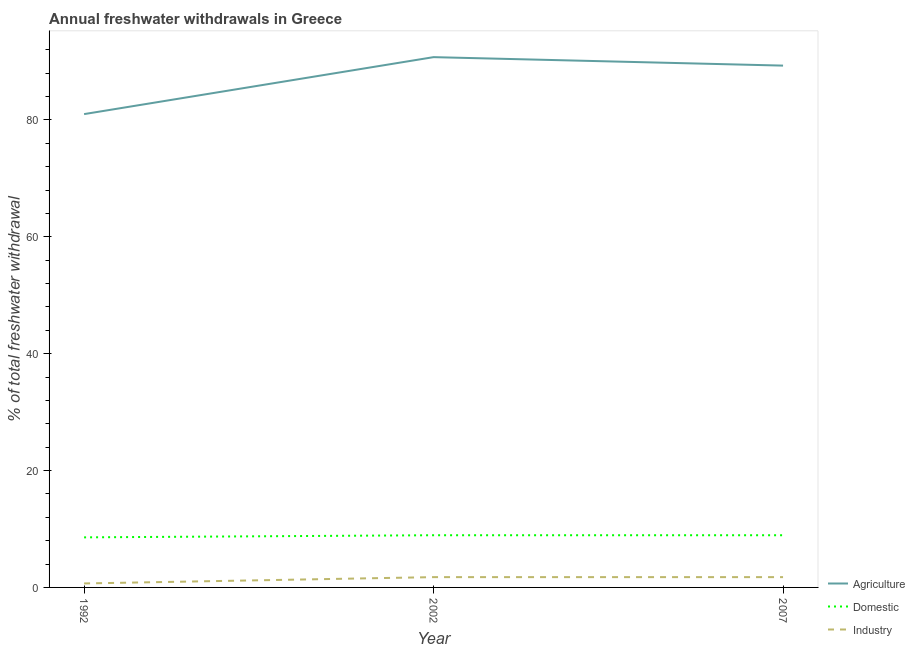What is the percentage of freshwater withdrawal for industry in 2007?
Provide a short and direct response. 1.76. Across all years, what is the maximum percentage of freshwater withdrawal for domestic purposes?
Offer a terse response. 8.93. Across all years, what is the minimum percentage of freshwater withdrawal for agriculture?
Your answer should be very brief. 81. In which year was the percentage of freshwater withdrawal for agriculture minimum?
Offer a terse response. 1992. What is the total percentage of freshwater withdrawal for agriculture in the graph?
Your answer should be compact. 261.05. What is the difference between the percentage of freshwater withdrawal for agriculture in 1992 and that in 2002?
Your answer should be very brief. -9.75. What is the difference between the percentage of freshwater withdrawal for agriculture in 1992 and the percentage of freshwater withdrawal for domestic purposes in 2002?
Make the answer very short. 72.07. What is the average percentage of freshwater withdrawal for domestic purposes per year?
Make the answer very short. 8.81. In the year 2002, what is the difference between the percentage of freshwater withdrawal for domestic purposes and percentage of freshwater withdrawal for industry?
Your answer should be very brief. 7.17. In how many years, is the percentage of freshwater withdrawal for agriculture greater than 48 %?
Make the answer very short. 3. What is the ratio of the percentage of freshwater withdrawal for industry in 2002 to that in 2007?
Give a very brief answer. 1. Is the percentage of freshwater withdrawal for industry in 2002 less than that in 2007?
Provide a succinct answer. No. What is the difference between the highest and the second highest percentage of freshwater withdrawal for agriculture?
Provide a succinct answer. 1.45. What is the difference between the highest and the lowest percentage of freshwater withdrawal for agriculture?
Give a very brief answer. 9.75. Is the percentage of freshwater withdrawal for domestic purposes strictly less than the percentage of freshwater withdrawal for industry over the years?
Your answer should be very brief. No. How many lines are there?
Your answer should be compact. 3. How many years are there in the graph?
Ensure brevity in your answer.  3. What is the difference between two consecutive major ticks on the Y-axis?
Give a very brief answer. 20. How many legend labels are there?
Provide a succinct answer. 3. How are the legend labels stacked?
Make the answer very short. Vertical. What is the title of the graph?
Offer a very short reply. Annual freshwater withdrawals in Greece. What is the label or title of the Y-axis?
Offer a terse response. % of total freshwater withdrawal. What is the % of total freshwater withdrawal of Domestic in 1992?
Provide a succinct answer. 8.57. What is the % of total freshwater withdrawal in Industry in 1992?
Provide a short and direct response. 0.68. What is the % of total freshwater withdrawal of Agriculture in 2002?
Offer a terse response. 90.75. What is the % of total freshwater withdrawal in Domestic in 2002?
Offer a very short reply. 8.93. What is the % of total freshwater withdrawal in Industry in 2002?
Offer a very short reply. 1.76. What is the % of total freshwater withdrawal in Agriculture in 2007?
Your answer should be very brief. 89.3. What is the % of total freshwater withdrawal of Domestic in 2007?
Ensure brevity in your answer.  8.93. What is the % of total freshwater withdrawal of Industry in 2007?
Keep it short and to the point. 1.76. Across all years, what is the maximum % of total freshwater withdrawal in Agriculture?
Your answer should be compact. 90.75. Across all years, what is the maximum % of total freshwater withdrawal in Domestic?
Your response must be concise. 8.93. Across all years, what is the maximum % of total freshwater withdrawal in Industry?
Offer a terse response. 1.76. Across all years, what is the minimum % of total freshwater withdrawal of Domestic?
Your answer should be very brief. 8.57. Across all years, what is the minimum % of total freshwater withdrawal of Industry?
Provide a short and direct response. 0.68. What is the total % of total freshwater withdrawal in Agriculture in the graph?
Provide a succinct answer. 261.05. What is the total % of total freshwater withdrawal of Domestic in the graph?
Your answer should be compact. 26.43. What is the total % of total freshwater withdrawal in Industry in the graph?
Provide a short and direct response. 4.21. What is the difference between the % of total freshwater withdrawal in Agriculture in 1992 and that in 2002?
Provide a short and direct response. -9.75. What is the difference between the % of total freshwater withdrawal in Domestic in 1992 and that in 2002?
Your answer should be compact. -0.36. What is the difference between the % of total freshwater withdrawal of Industry in 1992 and that in 2002?
Your answer should be compact. -1.08. What is the difference between the % of total freshwater withdrawal of Agriculture in 1992 and that in 2007?
Give a very brief answer. -8.3. What is the difference between the % of total freshwater withdrawal of Domestic in 1992 and that in 2007?
Provide a short and direct response. -0.36. What is the difference between the % of total freshwater withdrawal of Industry in 1992 and that in 2007?
Keep it short and to the point. -1.08. What is the difference between the % of total freshwater withdrawal of Agriculture in 2002 and that in 2007?
Your answer should be very brief. 1.45. What is the difference between the % of total freshwater withdrawal of Industry in 2002 and that in 2007?
Make the answer very short. 0. What is the difference between the % of total freshwater withdrawal in Agriculture in 1992 and the % of total freshwater withdrawal in Domestic in 2002?
Provide a short and direct response. 72.07. What is the difference between the % of total freshwater withdrawal in Agriculture in 1992 and the % of total freshwater withdrawal in Industry in 2002?
Provide a succinct answer. 79.24. What is the difference between the % of total freshwater withdrawal in Domestic in 1992 and the % of total freshwater withdrawal in Industry in 2002?
Ensure brevity in your answer.  6.81. What is the difference between the % of total freshwater withdrawal of Agriculture in 1992 and the % of total freshwater withdrawal of Domestic in 2007?
Keep it short and to the point. 72.07. What is the difference between the % of total freshwater withdrawal in Agriculture in 1992 and the % of total freshwater withdrawal in Industry in 2007?
Your answer should be compact. 79.24. What is the difference between the % of total freshwater withdrawal of Domestic in 1992 and the % of total freshwater withdrawal of Industry in 2007?
Give a very brief answer. 6.81. What is the difference between the % of total freshwater withdrawal in Agriculture in 2002 and the % of total freshwater withdrawal in Domestic in 2007?
Your answer should be compact. 81.82. What is the difference between the % of total freshwater withdrawal of Agriculture in 2002 and the % of total freshwater withdrawal of Industry in 2007?
Provide a succinct answer. 88.99. What is the difference between the % of total freshwater withdrawal of Domestic in 2002 and the % of total freshwater withdrawal of Industry in 2007?
Your response must be concise. 7.17. What is the average % of total freshwater withdrawal in Agriculture per year?
Give a very brief answer. 87.02. What is the average % of total freshwater withdrawal of Domestic per year?
Your answer should be very brief. 8.81. What is the average % of total freshwater withdrawal in Industry per year?
Your answer should be compact. 1.4. In the year 1992, what is the difference between the % of total freshwater withdrawal of Agriculture and % of total freshwater withdrawal of Domestic?
Offer a terse response. 72.43. In the year 1992, what is the difference between the % of total freshwater withdrawal in Agriculture and % of total freshwater withdrawal in Industry?
Give a very brief answer. 80.32. In the year 1992, what is the difference between the % of total freshwater withdrawal of Domestic and % of total freshwater withdrawal of Industry?
Your answer should be very brief. 7.89. In the year 2002, what is the difference between the % of total freshwater withdrawal in Agriculture and % of total freshwater withdrawal in Domestic?
Provide a short and direct response. 81.82. In the year 2002, what is the difference between the % of total freshwater withdrawal in Agriculture and % of total freshwater withdrawal in Industry?
Make the answer very short. 88.99. In the year 2002, what is the difference between the % of total freshwater withdrawal of Domestic and % of total freshwater withdrawal of Industry?
Your response must be concise. 7.17. In the year 2007, what is the difference between the % of total freshwater withdrawal in Agriculture and % of total freshwater withdrawal in Domestic?
Keep it short and to the point. 80.37. In the year 2007, what is the difference between the % of total freshwater withdrawal of Agriculture and % of total freshwater withdrawal of Industry?
Make the answer very short. 87.54. In the year 2007, what is the difference between the % of total freshwater withdrawal in Domestic and % of total freshwater withdrawal in Industry?
Your answer should be compact. 7.17. What is the ratio of the % of total freshwater withdrawal in Agriculture in 1992 to that in 2002?
Provide a short and direct response. 0.89. What is the ratio of the % of total freshwater withdrawal of Domestic in 1992 to that in 2002?
Ensure brevity in your answer.  0.96. What is the ratio of the % of total freshwater withdrawal in Industry in 1992 to that in 2002?
Offer a terse response. 0.39. What is the ratio of the % of total freshwater withdrawal in Agriculture in 1992 to that in 2007?
Keep it short and to the point. 0.91. What is the ratio of the % of total freshwater withdrawal of Domestic in 1992 to that in 2007?
Ensure brevity in your answer.  0.96. What is the ratio of the % of total freshwater withdrawal in Industry in 1992 to that in 2007?
Give a very brief answer. 0.39. What is the ratio of the % of total freshwater withdrawal of Agriculture in 2002 to that in 2007?
Your response must be concise. 1.02. What is the difference between the highest and the second highest % of total freshwater withdrawal of Agriculture?
Make the answer very short. 1.45. What is the difference between the highest and the second highest % of total freshwater withdrawal of Domestic?
Ensure brevity in your answer.  0. What is the difference between the highest and the second highest % of total freshwater withdrawal in Industry?
Offer a very short reply. 0. What is the difference between the highest and the lowest % of total freshwater withdrawal of Agriculture?
Your response must be concise. 9.75. What is the difference between the highest and the lowest % of total freshwater withdrawal of Domestic?
Provide a short and direct response. 0.36. What is the difference between the highest and the lowest % of total freshwater withdrawal of Industry?
Offer a very short reply. 1.08. 